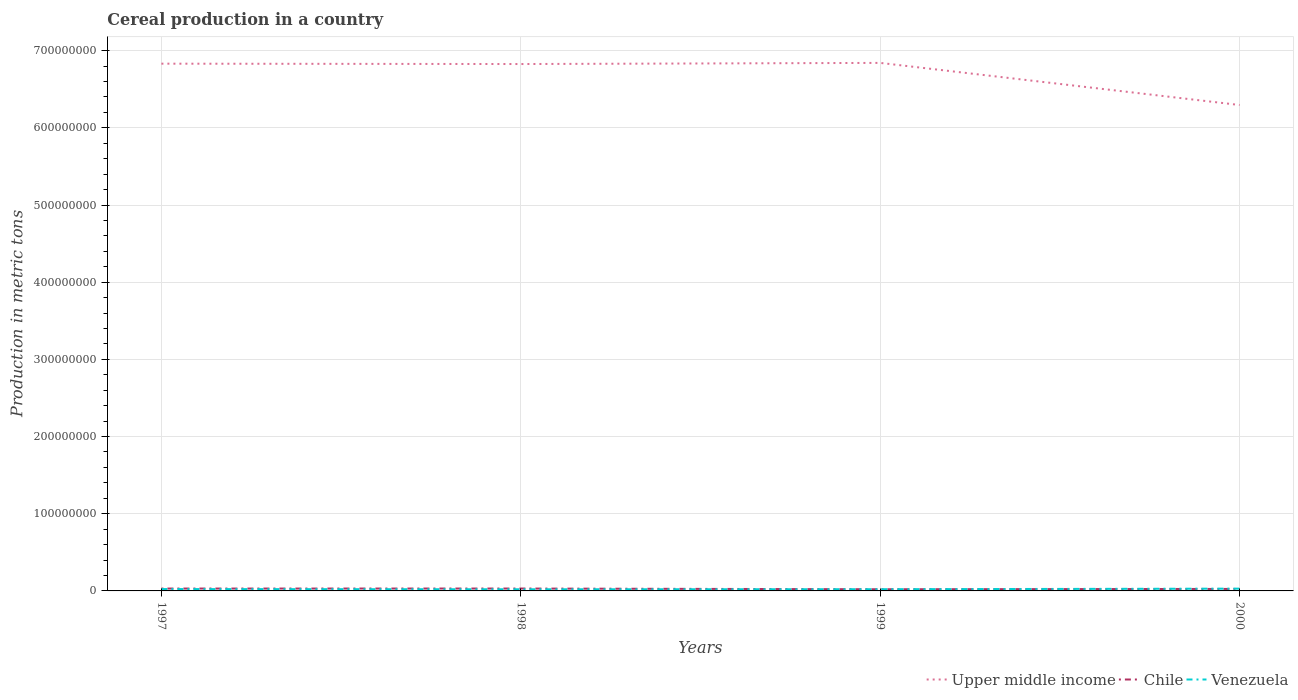Does the line corresponding to Venezuela intersect with the line corresponding to Chile?
Make the answer very short. Yes. Is the number of lines equal to the number of legend labels?
Provide a short and direct response. Yes. Across all years, what is the maximum total cereal production in Chile?
Provide a short and direct response. 2.17e+06. What is the total total cereal production in Upper middle income in the graph?
Your answer should be compact. 5.45e+07. What is the difference between the highest and the second highest total cereal production in Upper middle income?
Ensure brevity in your answer.  5.45e+07. What is the difference between the highest and the lowest total cereal production in Chile?
Your answer should be compact. 2. Is the total cereal production in Venezuela strictly greater than the total cereal production in Chile over the years?
Make the answer very short. No. How many lines are there?
Your answer should be compact. 3. How many years are there in the graph?
Offer a terse response. 4. What is the difference between two consecutive major ticks on the Y-axis?
Your response must be concise. 1.00e+08. How many legend labels are there?
Keep it short and to the point. 3. How are the legend labels stacked?
Offer a very short reply. Horizontal. What is the title of the graph?
Keep it short and to the point. Cereal production in a country. What is the label or title of the Y-axis?
Make the answer very short. Production in metric tons. What is the Production in metric tons in Upper middle income in 1997?
Ensure brevity in your answer.  6.83e+08. What is the Production in metric tons in Chile in 1997?
Make the answer very short. 3.08e+06. What is the Production in metric tons of Venezuela in 1997?
Keep it short and to the point. 2.41e+06. What is the Production in metric tons in Upper middle income in 1998?
Give a very brief answer. 6.83e+08. What is the Production in metric tons in Chile in 1998?
Your answer should be very brief. 3.10e+06. What is the Production in metric tons of Venezuela in 1998?
Your answer should be very brief. 2.13e+06. What is the Production in metric tons of Upper middle income in 1999?
Offer a very short reply. 6.84e+08. What is the Production in metric tons in Chile in 1999?
Offer a terse response. 2.17e+06. What is the Production in metric tons in Venezuela in 1999?
Ensure brevity in your answer.  2.23e+06. What is the Production in metric tons in Upper middle income in 2000?
Give a very brief answer. 6.30e+08. What is the Production in metric tons in Chile in 2000?
Offer a very short reply. 2.59e+06. What is the Production in metric tons in Venezuela in 2000?
Your response must be concise. 2.95e+06. Across all years, what is the maximum Production in metric tons of Upper middle income?
Give a very brief answer. 6.84e+08. Across all years, what is the maximum Production in metric tons of Chile?
Make the answer very short. 3.10e+06. Across all years, what is the maximum Production in metric tons of Venezuela?
Your answer should be very brief. 2.95e+06. Across all years, what is the minimum Production in metric tons of Upper middle income?
Offer a terse response. 6.30e+08. Across all years, what is the minimum Production in metric tons in Chile?
Keep it short and to the point. 2.17e+06. Across all years, what is the minimum Production in metric tons in Venezuela?
Provide a succinct answer. 2.13e+06. What is the total Production in metric tons of Upper middle income in the graph?
Give a very brief answer. 2.68e+09. What is the total Production in metric tons in Chile in the graph?
Make the answer very short. 1.09e+07. What is the total Production in metric tons in Venezuela in the graph?
Ensure brevity in your answer.  9.73e+06. What is the difference between the Production in metric tons of Upper middle income in 1997 and that in 1998?
Provide a succinct answer. 4.72e+05. What is the difference between the Production in metric tons in Chile in 1997 and that in 1998?
Provide a short and direct response. -2.07e+04. What is the difference between the Production in metric tons in Venezuela in 1997 and that in 1998?
Make the answer very short. 2.79e+05. What is the difference between the Production in metric tons in Upper middle income in 1997 and that in 1999?
Give a very brief answer. -1.00e+06. What is the difference between the Production in metric tons of Chile in 1997 and that in 1999?
Provide a short and direct response. 9.09e+05. What is the difference between the Production in metric tons of Venezuela in 1997 and that in 1999?
Provide a succinct answer. 1.79e+05. What is the difference between the Production in metric tons of Upper middle income in 1997 and that in 2000?
Your response must be concise. 5.35e+07. What is the difference between the Production in metric tons of Chile in 1997 and that in 2000?
Ensure brevity in your answer.  4.88e+05. What is the difference between the Production in metric tons of Venezuela in 1997 and that in 2000?
Provide a short and direct response. -5.35e+05. What is the difference between the Production in metric tons of Upper middle income in 1998 and that in 1999?
Offer a terse response. -1.47e+06. What is the difference between the Production in metric tons in Chile in 1998 and that in 1999?
Make the answer very short. 9.30e+05. What is the difference between the Production in metric tons of Venezuela in 1998 and that in 1999?
Your response must be concise. -1.00e+05. What is the difference between the Production in metric tons in Upper middle income in 1998 and that in 2000?
Your answer should be very brief. 5.31e+07. What is the difference between the Production in metric tons in Chile in 1998 and that in 2000?
Offer a very short reply. 5.08e+05. What is the difference between the Production in metric tons in Venezuela in 1998 and that in 2000?
Make the answer very short. -8.15e+05. What is the difference between the Production in metric tons of Upper middle income in 1999 and that in 2000?
Offer a terse response. 5.45e+07. What is the difference between the Production in metric tons of Chile in 1999 and that in 2000?
Make the answer very short. -4.22e+05. What is the difference between the Production in metric tons of Venezuela in 1999 and that in 2000?
Provide a short and direct response. -7.14e+05. What is the difference between the Production in metric tons of Upper middle income in 1997 and the Production in metric tons of Chile in 1998?
Keep it short and to the point. 6.80e+08. What is the difference between the Production in metric tons in Upper middle income in 1997 and the Production in metric tons in Venezuela in 1998?
Provide a short and direct response. 6.81e+08. What is the difference between the Production in metric tons of Chile in 1997 and the Production in metric tons of Venezuela in 1998?
Your answer should be compact. 9.44e+05. What is the difference between the Production in metric tons of Upper middle income in 1997 and the Production in metric tons of Chile in 1999?
Keep it short and to the point. 6.81e+08. What is the difference between the Production in metric tons of Upper middle income in 1997 and the Production in metric tons of Venezuela in 1999?
Give a very brief answer. 6.81e+08. What is the difference between the Production in metric tons in Chile in 1997 and the Production in metric tons in Venezuela in 1999?
Provide a short and direct response. 8.43e+05. What is the difference between the Production in metric tons in Upper middle income in 1997 and the Production in metric tons in Chile in 2000?
Provide a succinct answer. 6.81e+08. What is the difference between the Production in metric tons in Upper middle income in 1997 and the Production in metric tons in Venezuela in 2000?
Your answer should be compact. 6.80e+08. What is the difference between the Production in metric tons of Chile in 1997 and the Production in metric tons of Venezuela in 2000?
Offer a very short reply. 1.29e+05. What is the difference between the Production in metric tons of Upper middle income in 1998 and the Production in metric tons of Chile in 1999?
Your response must be concise. 6.80e+08. What is the difference between the Production in metric tons in Upper middle income in 1998 and the Production in metric tons in Venezuela in 1999?
Your answer should be compact. 6.80e+08. What is the difference between the Production in metric tons in Chile in 1998 and the Production in metric tons in Venezuela in 1999?
Provide a succinct answer. 8.64e+05. What is the difference between the Production in metric tons in Upper middle income in 1998 and the Production in metric tons in Chile in 2000?
Make the answer very short. 6.80e+08. What is the difference between the Production in metric tons in Upper middle income in 1998 and the Production in metric tons in Venezuela in 2000?
Ensure brevity in your answer.  6.80e+08. What is the difference between the Production in metric tons of Chile in 1998 and the Production in metric tons of Venezuela in 2000?
Your answer should be very brief. 1.50e+05. What is the difference between the Production in metric tons in Upper middle income in 1999 and the Production in metric tons in Chile in 2000?
Your answer should be compact. 6.82e+08. What is the difference between the Production in metric tons in Upper middle income in 1999 and the Production in metric tons in Venezuela in 2000?
Offer a very short reply. 6.81e+08. What is the difference between the Production in metric tons in Chile in 1999 and the Production in metric tons in Venezuela in 2000?
Your answer should be compact. -7.80e+05. What is the average Production in metric tons of Upper middle income per year?
Offer a very short reply. 6.70e+08. What is the average Production in metric tons of Chile per year?
Your answer should be compact. 2.73e+06. What is the average Production in metric tons in Venezuela per year?
Your answer should be compact. 2.43e+06. In the year 1997, what is the difference between the Production in metric tons of Upper middle income and Production in metric tons of Chile?
Offer a terse response. 6.80e+08. In the year 1997, what is the difference between the Production in metric tons in Upper middle income and Production in metric tons in Venezuela?
Provide a short and direct response. 6.81e+08. In the year 1997, what is the difference between the Production in metric tons of Chile and Production in metric tons of Venezuela?
Offer a terse response. 6.64e+05. In the year 1998, what is the difference between the Production in metric tons in Upper middle income and Production in metric tons in Chile?
Make the answer very short. 6.80e+08. In the year 1998, what is the difference between the Production in metric tons of Upper middle income and Production in metric tons of Venezuela?
Your answer should be very brief. 6.81e+08. In the year 1998, what is the difference between the Production in metric tons of Chile and Production in metric tons of Venezuela?
Keep it short and to the point. 9.64e+05. In the year 1999, what is the difference between the Production in metric tons of Upper middle income and Production in metric tons of Chile?
Give a very brief answer. 6.82e+08. In the year 1999, what is the difference between the Production in metric tons of Upper middle income and Production in metric tons of Venezuela?
Provide a succinct answer. 6.82e+08. In the year 1999, what is the difference between the Production in metric tons of Chile and Production in metric tons of Venezuela?
Offer a very short reply. -6.61e+04. In the year 2000, what is the difference between the Production in metric tons of Upper middle income and Production in metric tons of Chile?
Keep it short and to the point. 6.27e+08. In the year 2000, what is the difference between the Production in metric tons in Upper middle income and Production in metric tons in Venezuela?
Offer a very short reply. 6.27e+08. In the year 2000, what is the difference between the Production in metric tons of Chile and Production in metric tons of Venezuela?
Keep it short and to the point. -3.59e+05. What is the ratio of the Production in metric tons in Chile in 1997 to that in 1998?
Provide a short and direct response. 0.99. What is the ratio of the Production in metric tons of Venezuela in 1997 to that in 1998?
Offer a very short reply. 1.13. What is the ratio of the Production in metric tons in Upper middle income in 1997 to that in 1999?
Your answer should be very brief. 1. What is the ratio of the Production in metric tons of Chile in 1997 to that in 1999?
Offer a very short reply. 1.42. What is the ratio of the Production in metric tons in Venezuela in 1997 to that in 1999?
Your response must be concise. 1.08. What is the ratio of the Production in metric tons in Upper middle income in 1997 to that in 2000?
Keep it short and to the point. 1.09. What is the ratio of the Production in metric tons in Chile in 1997 to that in 2000?
Provide a succinct answer. 1.19. What is the ratio of the Production in metric tons in Venezuela in 1997 to that in 2000?
Give a very brief answer. 0.82. What is the ratio of the Production in metric tons of Chile in 1998 to that in 1999?
Your answer should be very brief. 1.43. What is the ratio of the Production in metric tons of Venezuela in 1998 to that in 1999?
Provide a succinct answer. 0.96. What is the ratio of the Production in metric tons of Upper middle income in 1998 to that in 2000?
Give a very brief answer. 1.08. What is the ratio of the Production in metric tons in Chile in 1998 to that in 2000?
Make the answer very short. 1.2. What is the ratio of the Production in metric tons in Venezuela in 1998 to that in 2000?
Give a very brief answer. 0.72. What is the ratio of the Production in metric tons in Upper middle income in 1999 to that in 2000?
Your answer should be very brief. 1.09. What is the ratio of the Production in metric tons of Chile in 1999 to that in 2000?
Provide a short and direct response. 0.84. What is the ratio of the Production in metric tons of Venezuela in 1999 to that in 2000?
Offer a very short reply. 0.76. What is the difference between the highest and the second highest Production in metric tons in Upper middle income?
Your answer should be compact. 1.00e+06. What is the difference between the highest and the second highest Production in metric tons in Chile?
Your answer should be very brief. 2.07e+04. What is the difference between the highest and the second highest Production in metric tons in Venezuela?
Your answer should be compact. 5.35e+05. What is the difference between the highest and the lowest Production in metric tons in Upper middle income?
Offer a very short reply. 5.45e+07. What is the difference between the highest and the lowest Production in metric tons of Chile?
Your answer should be very brief. 9.30e+05. What is the difference between the highest and the lowest Production in metric tons of Venezuela?
Your answer should be very brief. 8.15e+05. 